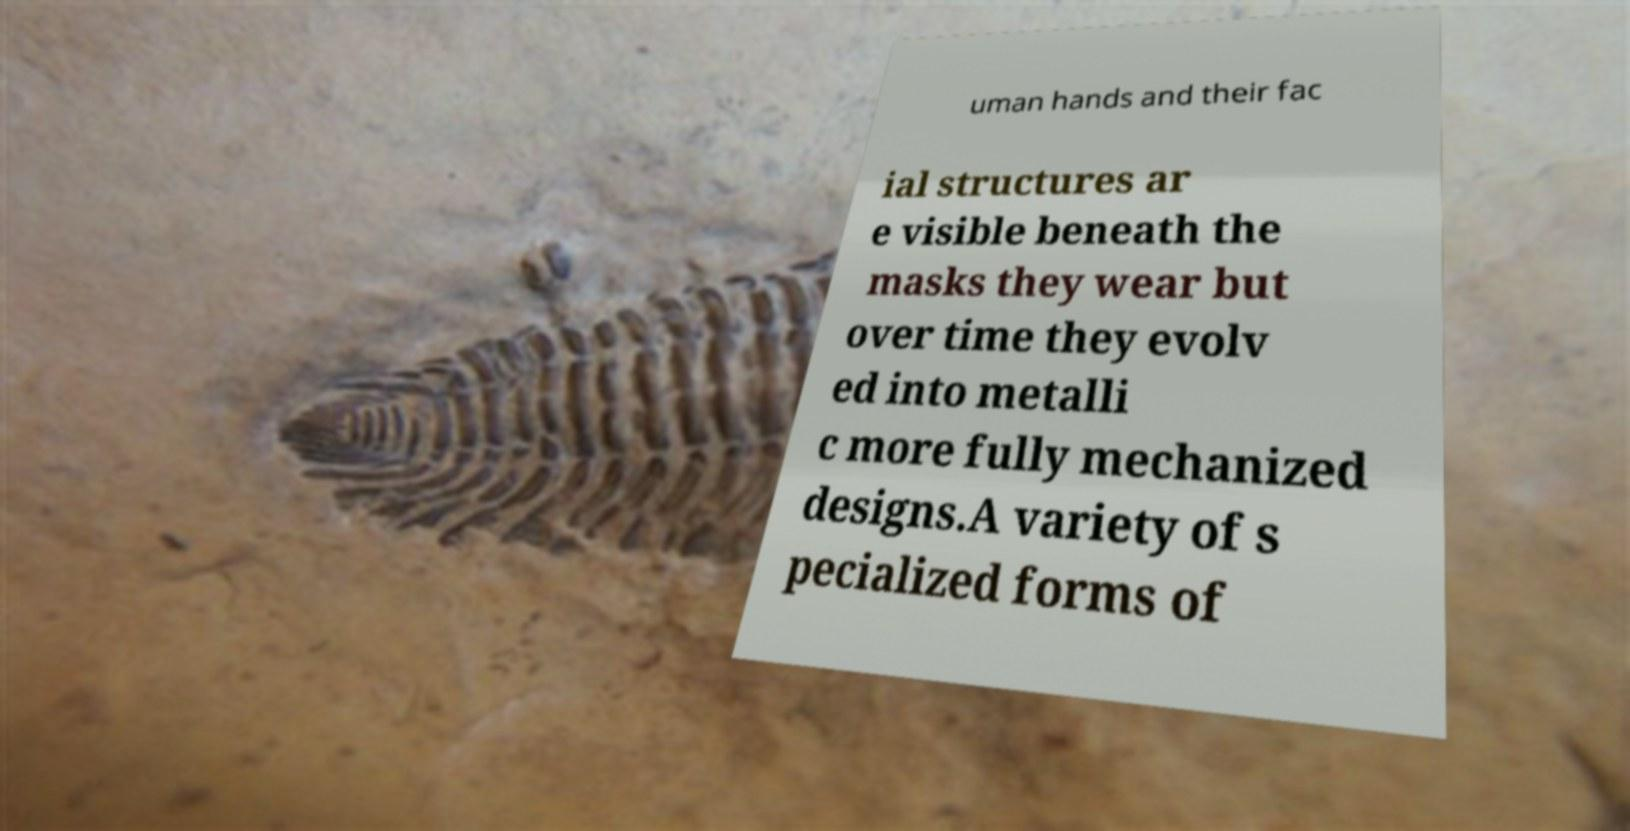There's text embedded in this image that I need extracted. Can you transcribe it verbatim? uman hands and their fac ial structures ar e visible beneath the masks they wear but over time they evolv ed into metalli c more fully mechanized designs.A variety of s pecialized forms of 